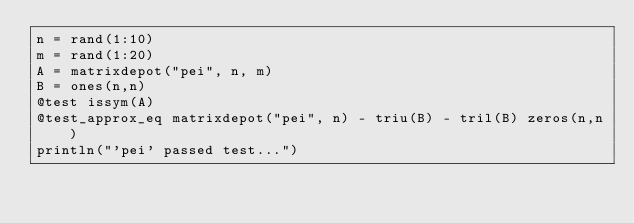Convert code to text. <code><loc_0><loc_0><loc_500><loc_500><_Julia_>n = rand(1:10)
m = rand(1:20)
A = matrixdepot("pei", n, m)
B = ones(n,n)
@test issym(A)
@test_approx_eq matrixdepot("pei", n) - triu(B) - tril(B) zeros(n,n)
println("'pei' passed test...") 
</code> 